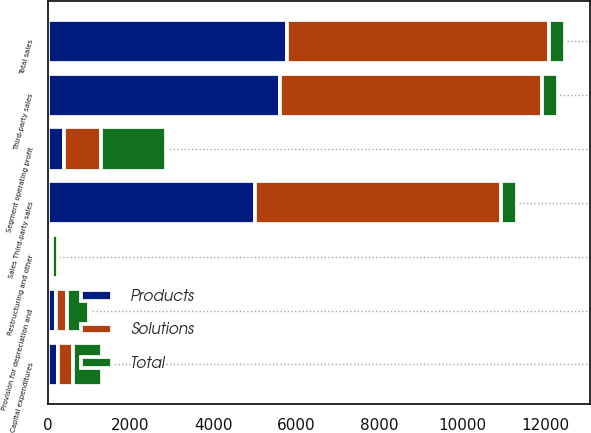<chart> <loc_0><loc_0><loc_500><loc_500><stacked_bar_chart><ecel><fcel>Third-party sales<fcel>Total sales<fcel>Segment operating profit<fcel>Restructuring and other<fcel>Sales Third-party sales<fcel>Provision for depreciation and<fcel>Capital expenditures<nl><fcel>Solutions<fcel>6316<fcel>6316<fcel>891<fcel>30<fcel>5943<fcel>268<fcel>349<nl><fcel>Products<fcel>5604<fcel>5764<fcel>386<fcel>72<fcel>5000<fcel>205<fcel>255<nl><fcel>Total<fcel>386<fcel>386<fcel>1581<fcel>154<fcel>386<fcel>523<fcel>715<nl></chart> 